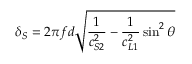<formula> <loc_0><loc_0><loc_500><loc_500>\delta _ { S } = 2 \pi f d \sqrt { \frac { 1 } { c _ { S 2 } ^ { 2 } } - \frac { 1 } { c _ { L 1 } ^ { 2 } } \sin ^ { 2 } \theta }</formula> 